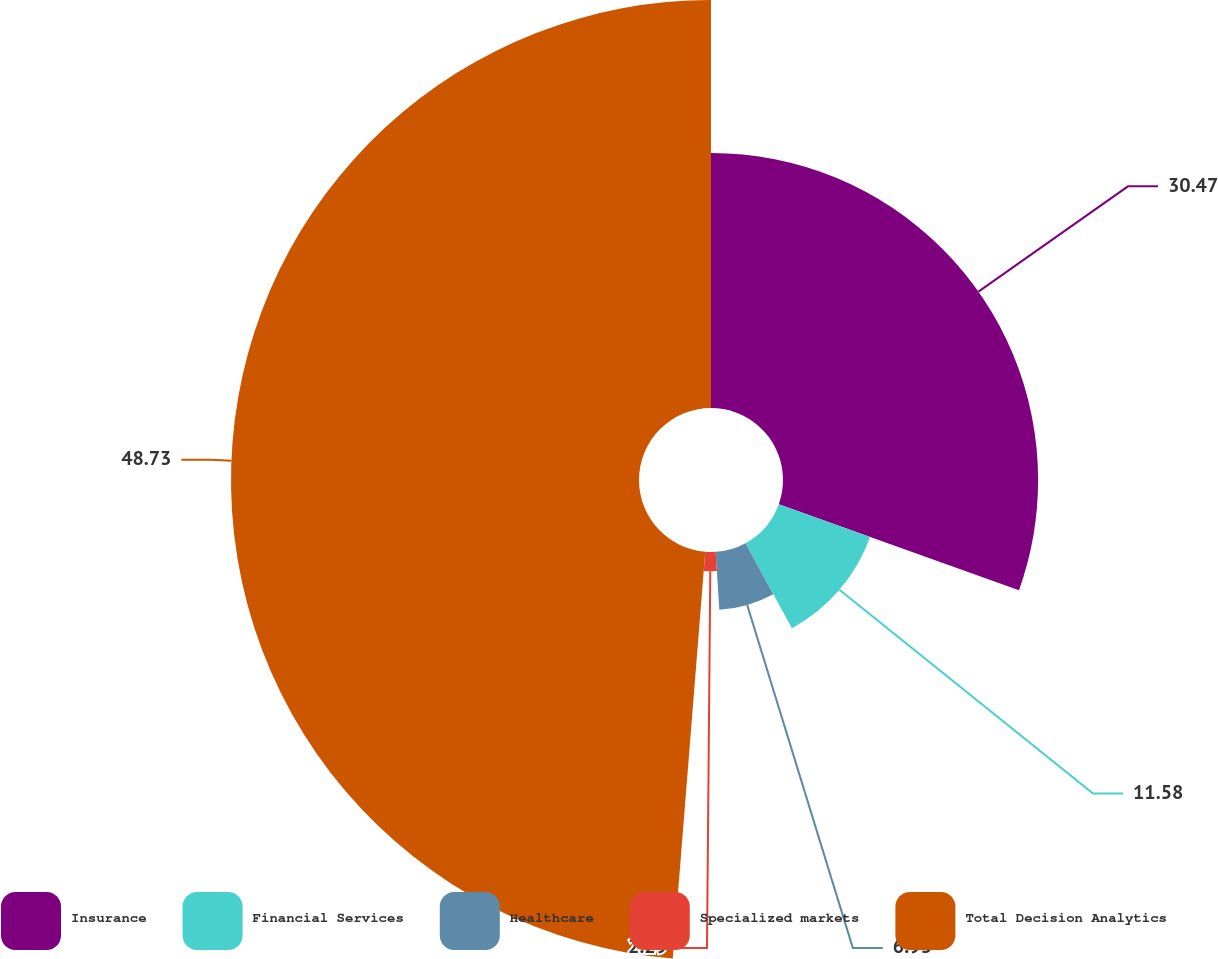Convert chart to OTSL. <chart><loc_0><loc_0><loc_500><loc_500><pie_chart><fcel>Insurance<fcel>Financial Services<fcel>Healthcare<fcel>Specialized markets<fcel>Total Decision Analytics<nl><fcel>30.47%<fcel>11.58%<fcel>6.93%<fcel>2.29%<fcel>48.73%<nl></chart> 